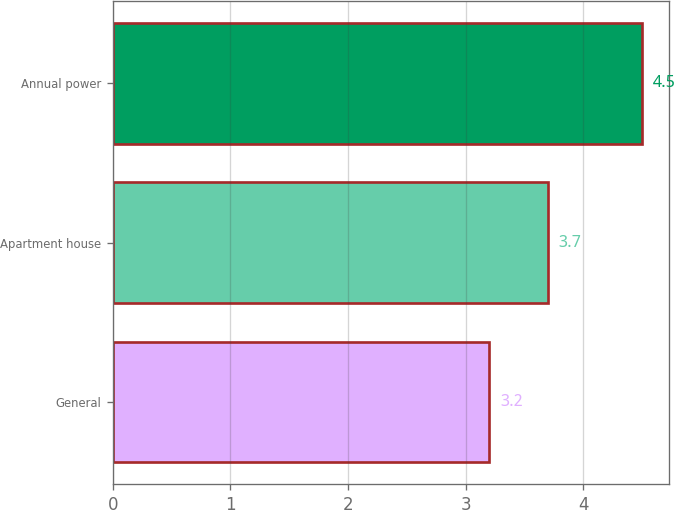Convert chart to OTSL. <chart><loc_0><loc_0><loc_500><loc_500><bar_chart><fcel>General<fcel>Apartment house<fcel>Annual power<nl><fcel>3.2<fcel>3.7<fcel>4.5<nl></chart> 